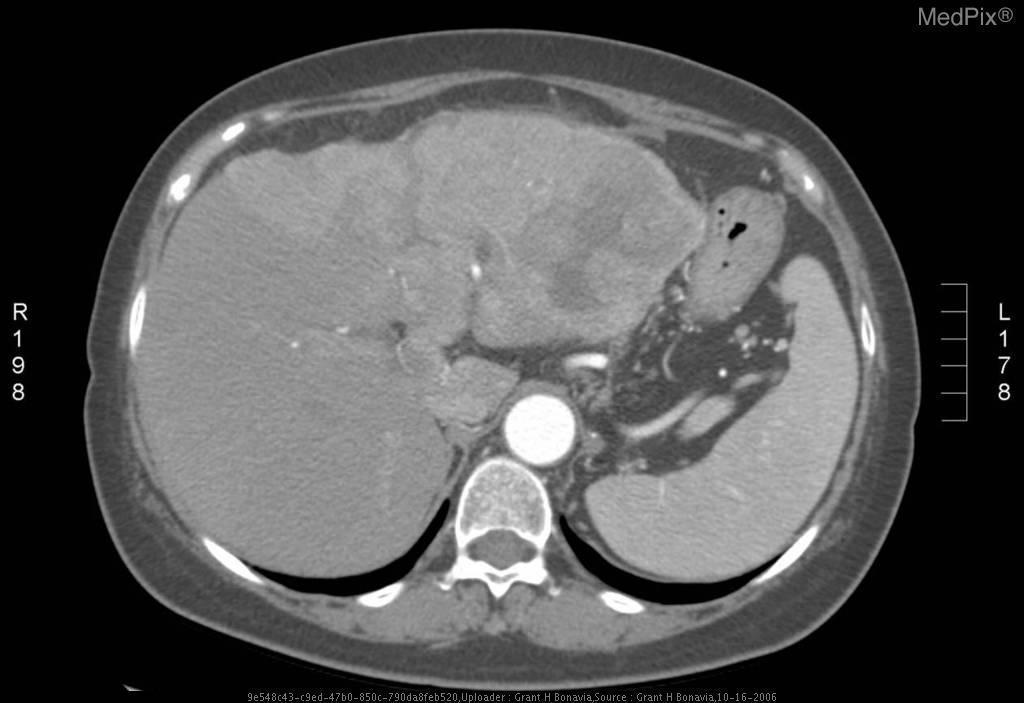Is there contrast used in the above image?
Give a very brief answer. Yes. This image is suspicious of what cancerous pathology?
Give a very brief answer. Hepatocellular carcioma. What cancer does this patient have?
Be succinct. Hepatocellular carcioma. What vascular problem is seen above?
Short answer required. Portal vein occlusion. What vein is occluded?
Keep it brief. Portal vein. Are there any abnormalities seen in the spleen?
Concise answer only. No. What is the pathology seen in the spleen?
Write a very short answer. Nothing. 